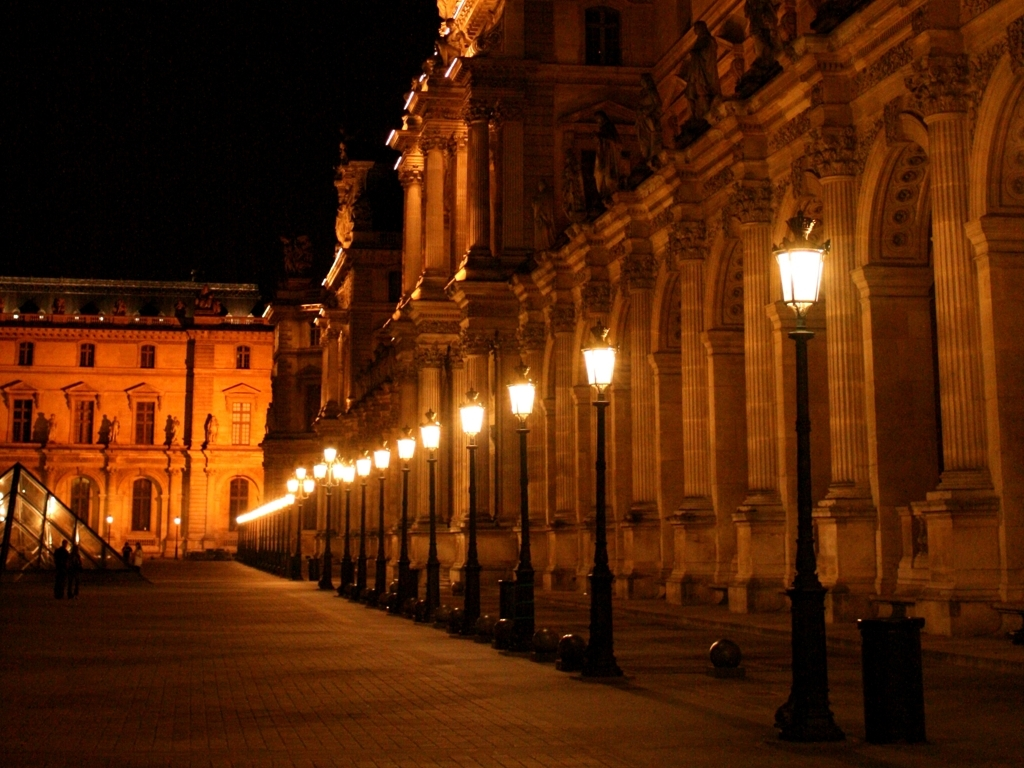Is the frame well-filled?
A. Yes
B. No
Answer with the option's letter from the given choices directly.
 A. 